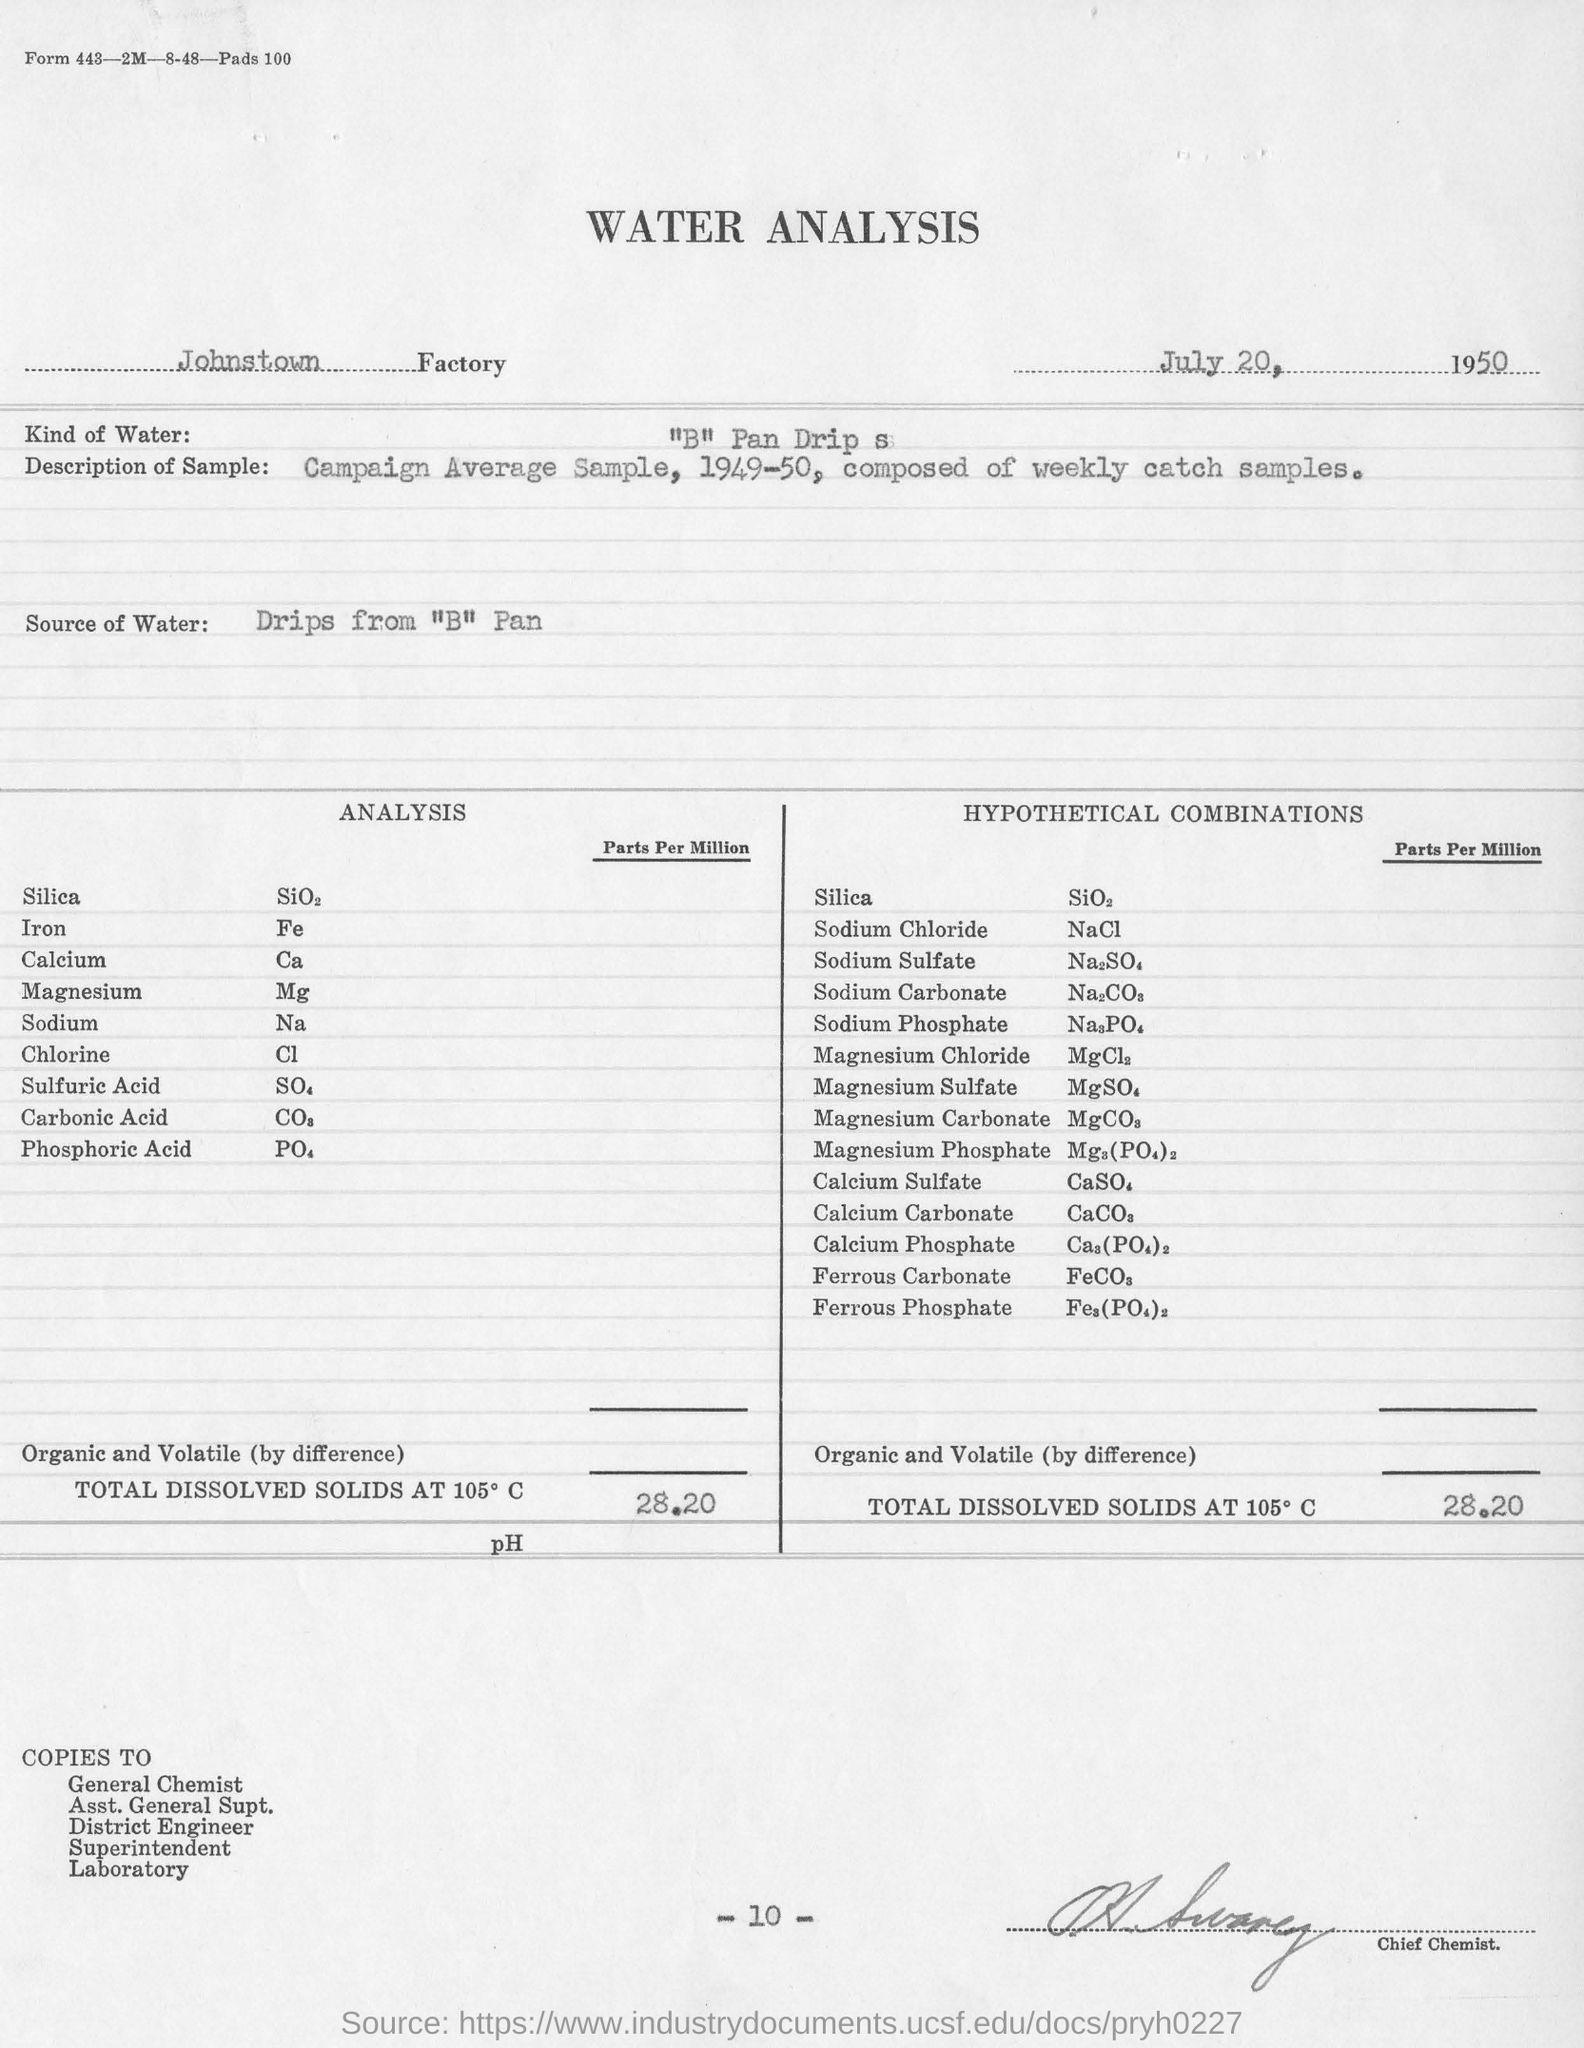Indicate a few pertinent items in this graphic. The water used for analysis was obtained from drips from a pan labeled "B. The page number mentioned in this document is 10. The person signed is designated as the Chief Chemist. The analysis for the Johnstown Factory was conducted at the Johnstown Factory. The type of water used for analysis is typically "B" Pan Drip s.. 